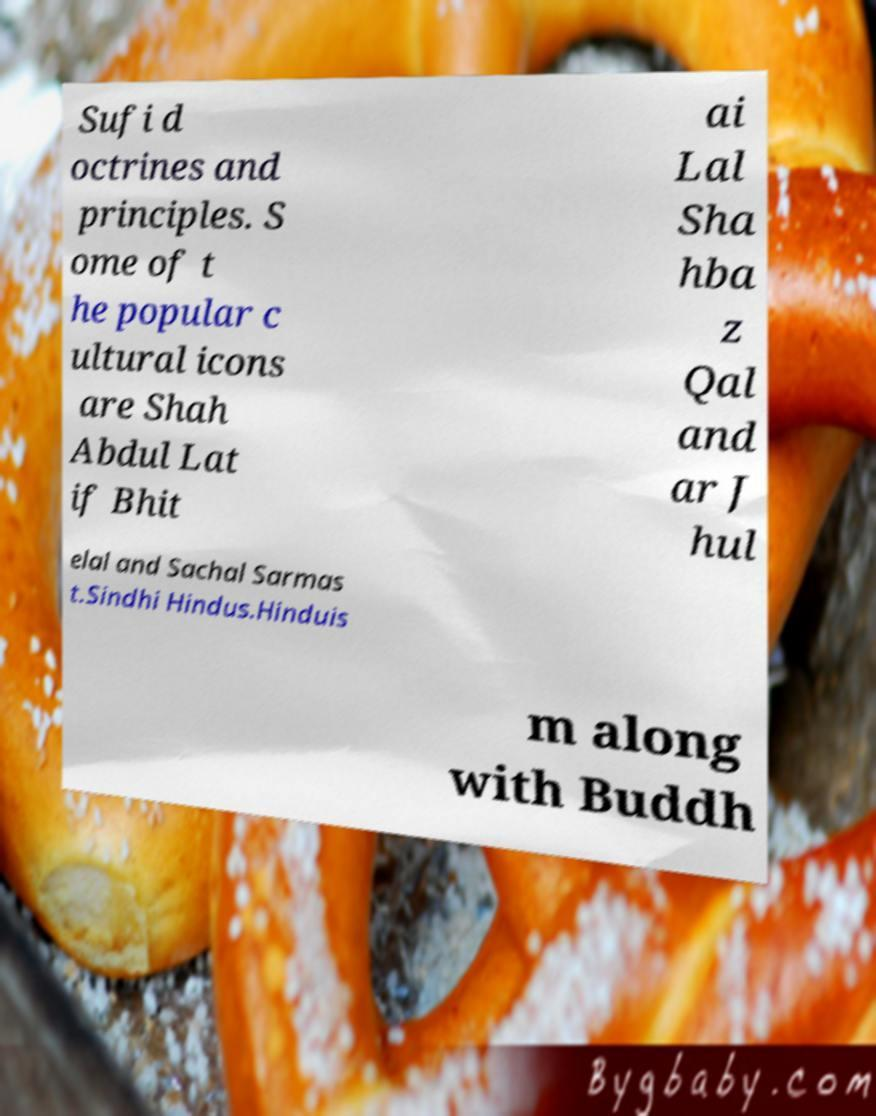Please identify and transcribe the text found in this image. Sufi d octrines and principles. S ome of t he popular c ultural icons are Shah Abdul Lat if Bhit ai Lal Sha hba z Qal and ar J hul elal and Sachal Sarmas t.Sindhi Hindus.Hinduis m along with Buddh 